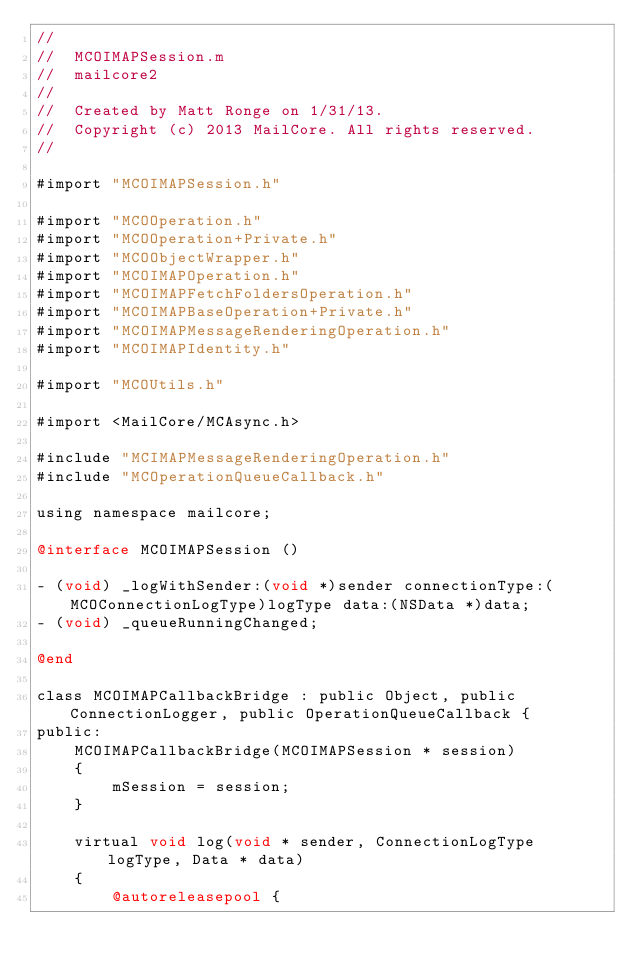Convert code to text. <code><loc_0><loc_0><loc_500><loc_500><_ObjectiveC_>//
//  MCOIMAPSession.m
//  mailcore2
//
//  Created by Matt Ronge on 1/31/13.
//  Copyright (c) 2013 MailCore. All rights reserved.
//

#import "MCOIMAPSession.h"

#import "MCOOperation.h"
#import "MCOOperation+Private.h"
#import "MCOObjectWrapper.h"
#import "MCOIMAPOperation.h"
#import "MCOIMAPFetchFoldersOperation.h"
#import "MCOIMAPBaseOperation+Private.h"
#import "MCOIMAPMessageRenderingOperation.h"
#import "MCOIMAPIdentity.h"

#import "MCOUtils.h"

#import <MailCore/MCAsync.h>

#include "MCIMAPMessageRenderingOperation.h"
#include "MCOperationQueueCallback.h"

using namespace mailcore;

@interface MCOIMAPSession ()

- (void) _logWithSender:(void *)sender connectionType:(MCOConnectionLogType)logType data:(NSData *)data;
- (void) _queueRunningChanged;

@end

class MCOIMAPCallbackBridge : public Object, public ConnectionLogger, public OperationQueueCallback {
public:
    MCOIMAPCallbackBridge(MCOIMAPSession * session)
    {
        mSession = session;
    }
    
    virtual void log(void * sender, ConnectionLogType logType, Data * data)
    {
        @autoreleasepool {</code> 